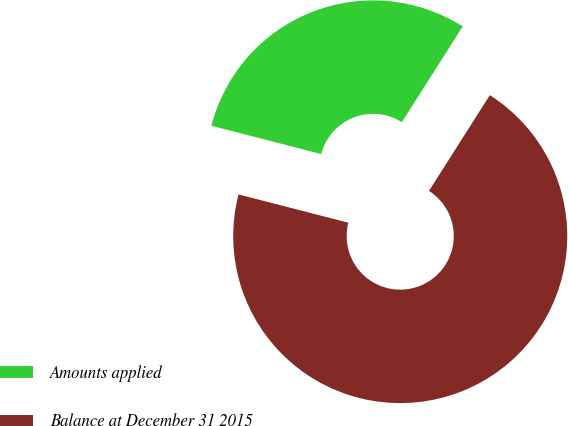<chart> <loc_0><loc_0><loc_500><loc_500><pie_chart><fcel>Amounts applied<fcel>Balance at December 31 2015<nl><fcel>30.0%<fcel>70.0%<nl></chart> 